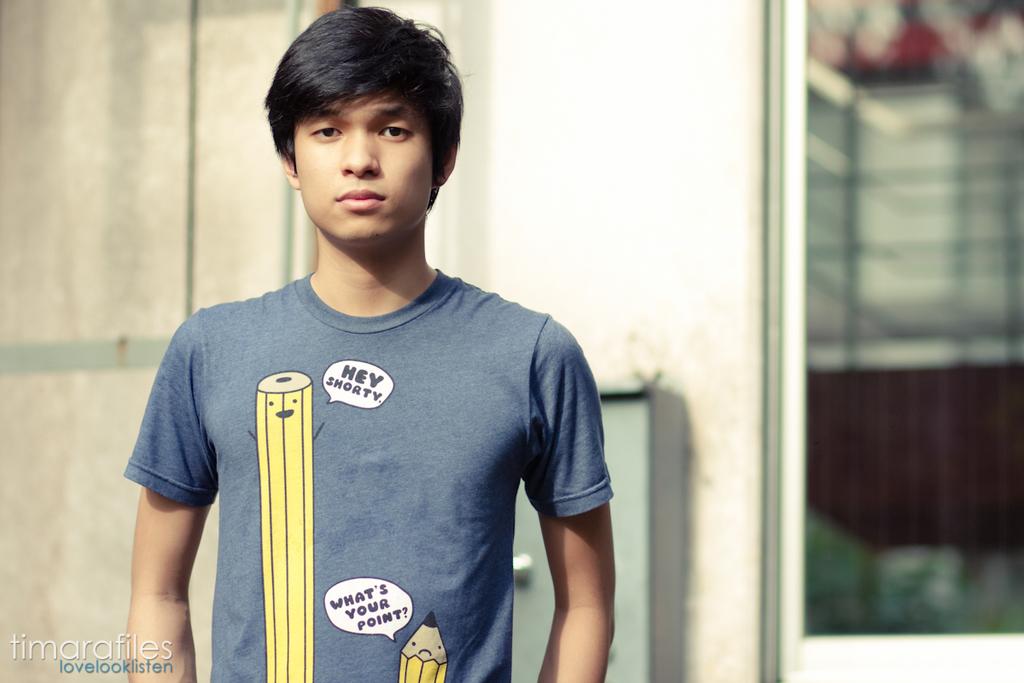What is the little pencil saying?
Offer a terse response. What's your point?. What is the big pencil saying?
Your response must be concise. Hey shorty. 